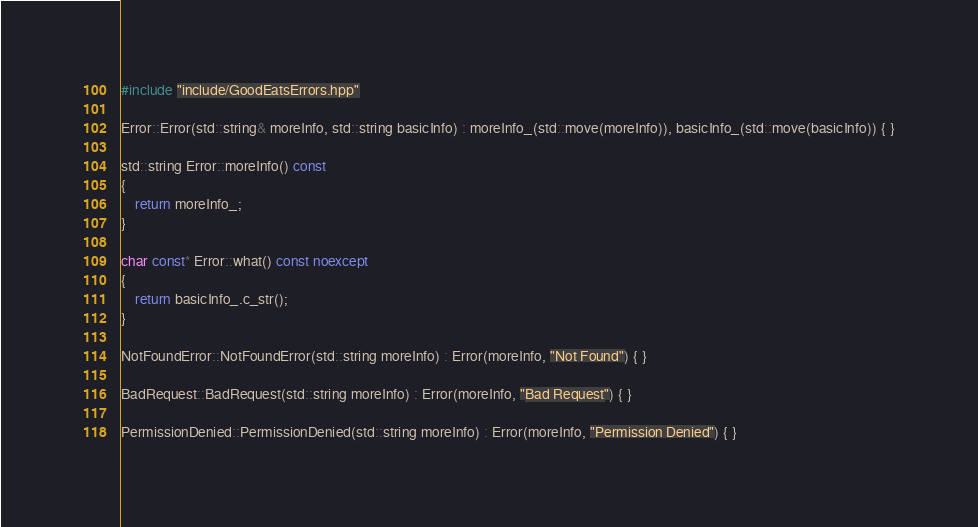<code> <loc_0><loc_0><loc_500><loc_500><_C++_>#include "include/GoodEatsErrors.hpp"

Error::Error(std::string& moreInfo, std::string basicInfo) : moreInfo_(std::move(moreInfo)), basicInfo_(std::move(basicInfo)) { }

std::string Error::moreInfo() const
{
	return moreInfo_;
}

char const* Error::what() const noexcept
{
	return basicInfo_.c_str();
}

NotFoundError::NotFoundError(std::string moreInfo) : Error(moreInfo, "Not Found") { }

BadRequest::BadRequest(std::string moreInfo) : Error(moreInfo, "Bad Request") { }

PermissionDenied::PermissionDenied(std::string moreInfo) : Error(moreInfo, "Permission Denied") { }
</code> 